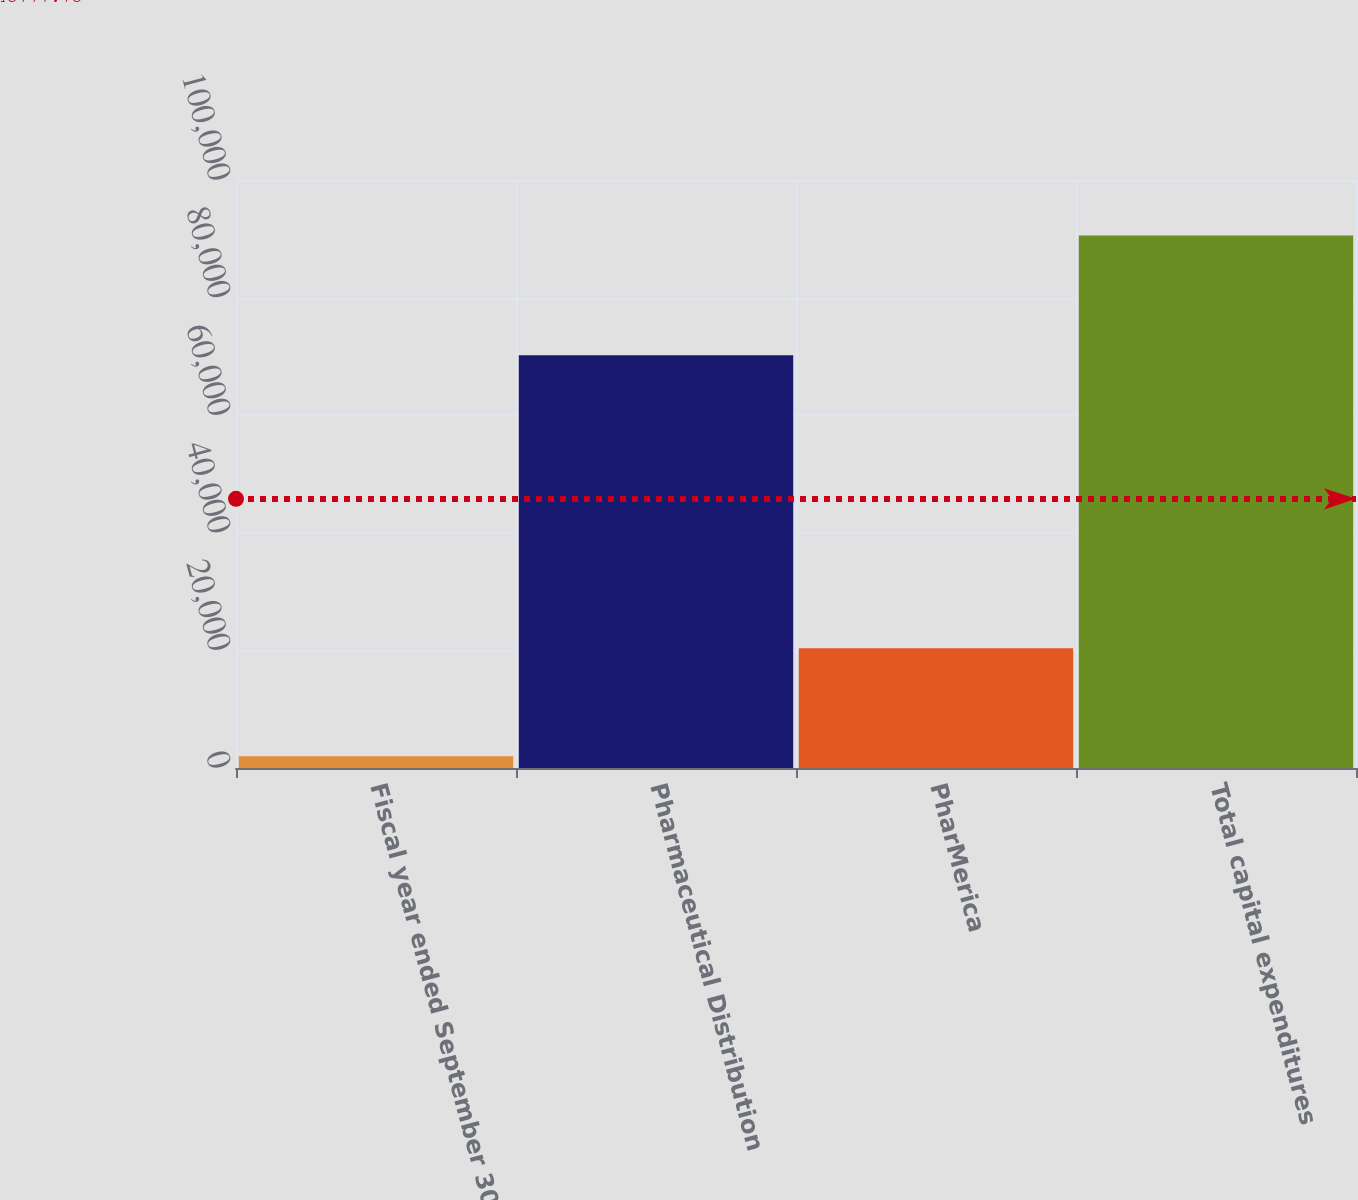<chart> <loc_0><loc_0><loc_500><loc_500><bar_chart><fcel>Fiscal year ended September 30<fcel>Pharmaceutical Distribution<fcel>PharMerica<fcel>Total capital expenditures<nl><fcel>2003<fcel>70207<fcel>20347<fcel>90554<nl></chart> 